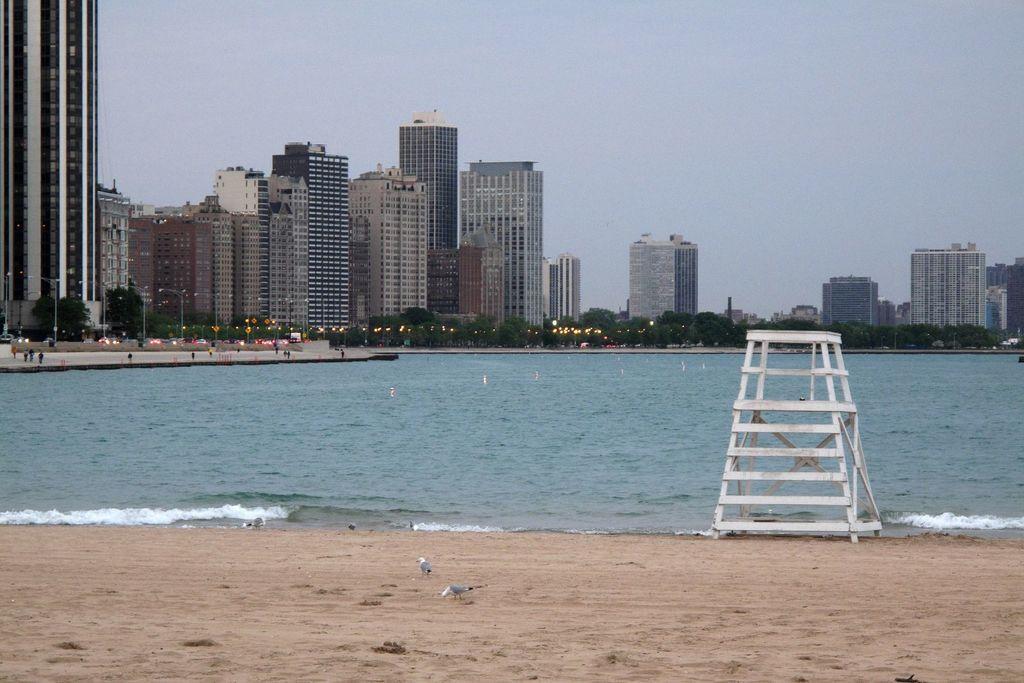How would you summarize this image in a sentence or two? On the right side of the image we can see a ladder. At the bottom there is sand and we can see birds. In the center there is water. In the background there are buildings, trees and sky. We can see people. 